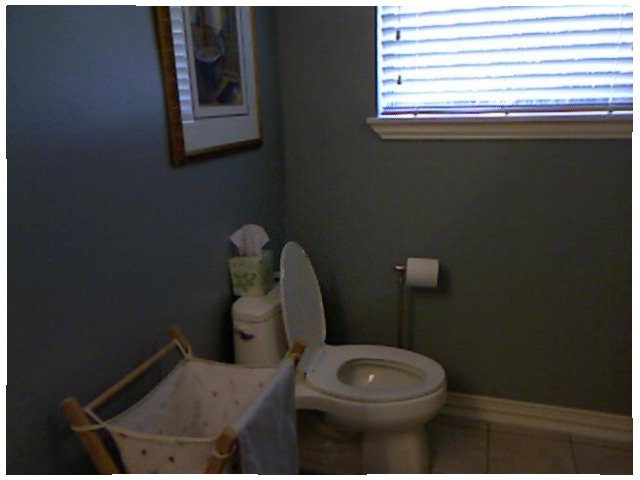<image>
Is there a toilet in front of the toilet paper? Yes. The toilet is positioned in front of the toilet paper, appearing closer to the camera viewpoint. Is the tissues on the toilet? Yes. Looking at the image, I can see the tissues is positioned on top of the toilet, with the toilet providing support. Is the toilet paper in the toilet? No. The toilet paper is not contained within the toilet. These objects have a different spatial relationship. Is there a toilet next to the toilet paper? Yes. The toilet is positioned adjacent to the toilet paper, located nearby in the same general area. 